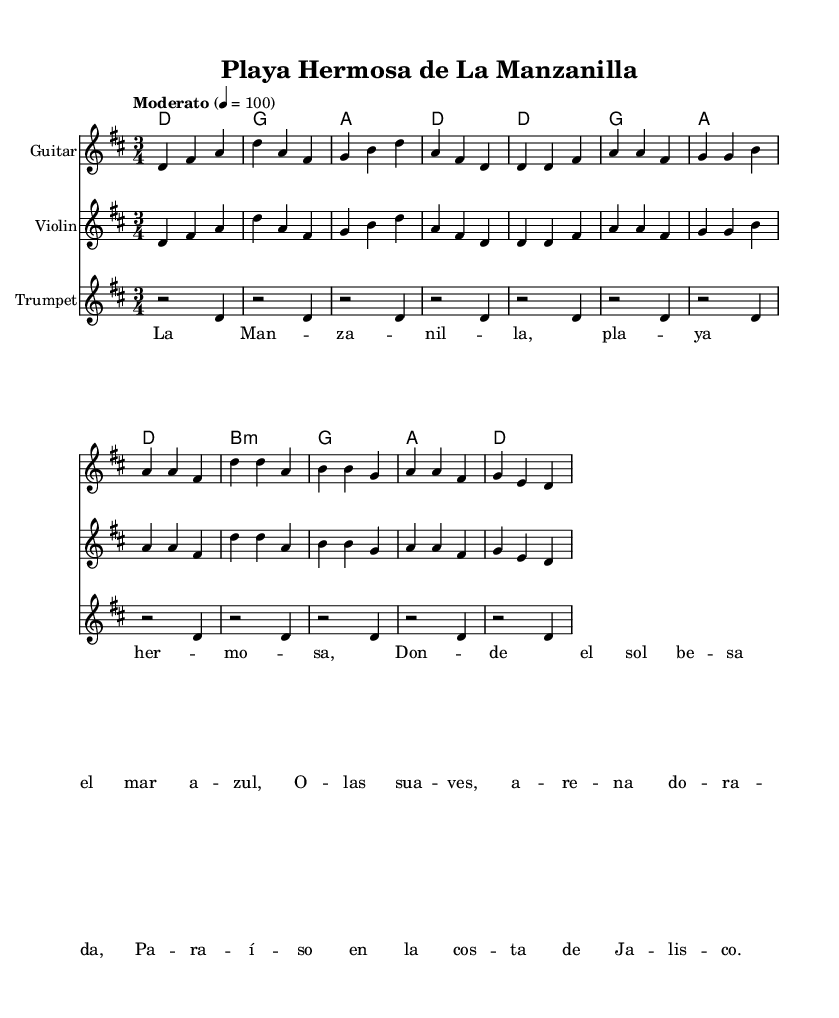What is the key signature of this music? The key signature is D major, which has two sharps: F# and C#. This can be deduced from the notation in the global music section where it explicitly states \key d \major.
Answer: D major What is the time signature of this music? The time signature is 3/4, indicating that there are three beats per measure and that the quarter note gets one beat. This is indicated by the \time 3/4 in the global music section.
Answer: 3/4 What is the tempo marking of this piece? The tempo marking is "Moderato" with a metronome marking of quarter note equals 100. This can be identified in the global music section which includes the tempo directive.
Answer: Moderato How many measures are in the chorus? The chorus consists of 4 measures, as indicated by the music notation where each line is divided into measures. Each line ends after the fourth note, confirming it is four measures long.
Answer: 4 Which instruments are included in this arrangement? The arrangement includes Guitar, Violin, and Trumpet. These instruments are indicated in their respective staff sections in the score. One can see the labels above each instrument staff.
Answer: Guitar, Violin, Trumpet What is the theme of the lyrics presented? The theme of the lyrics celebrates the beauty of La Manzanilla and its coastal environment. The lyrics reflect the feeling of admiration for the beach and nature of Jalisco. This can be inferred from the content of the lyrics provided in the score.
Answer: La Manzanilla's coastal beauty Which chord is used in the first measure of the guitar? The chord used in the first measure of the guitar is D major. This is evident from the chords notated above the staff in the chord mode section.
Answer: D 